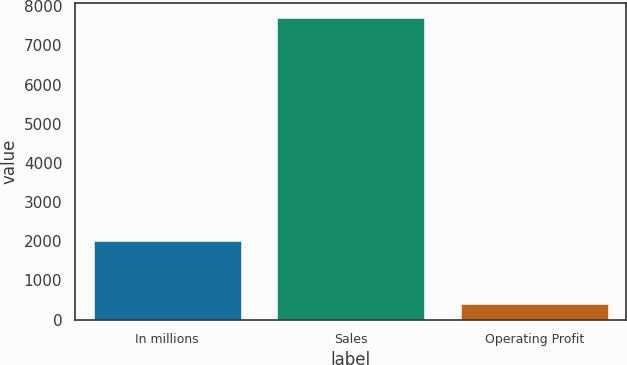Convert chart. <chart><loc_0><loc_0><loc_500><loc_500><bar_chart><fcel>In millions<fcel>Sales<fcel>Operating Profit<nl><fcel>2008<fcel>7690<fcel>390<nl></chart> 